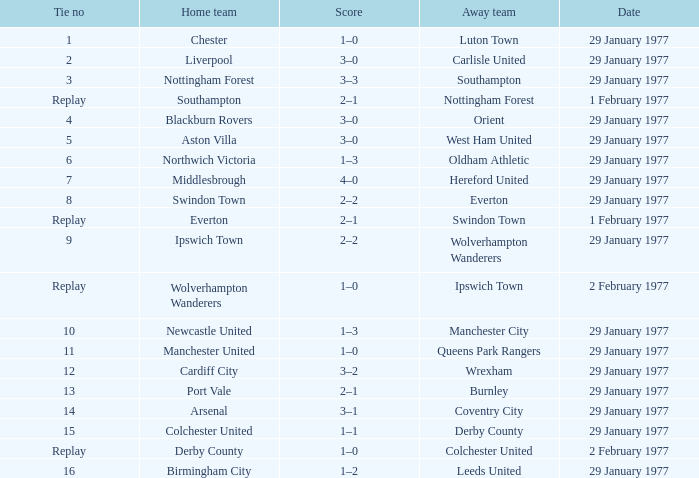Which away team has a tie number of 3? Southampton. 